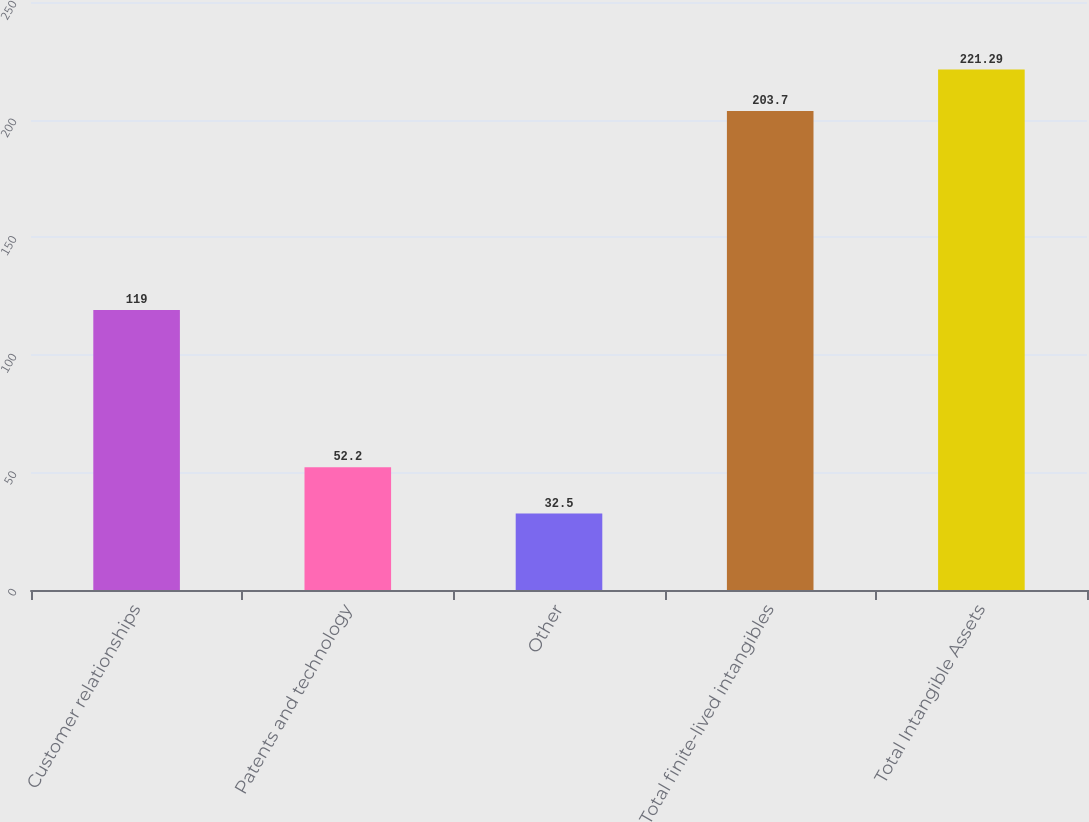Convert chart. <chart><loc_0><loc_0><loc_500><loc_500><bar_chart><fcel>Customer relationships<fcel>Patents and technology<fcel>Other<fcel>Total finite-lived intangibles<fcel>Total Intangible Assets<nl><fcel>119<fcel>52.2<fcel>32.5<fcel>203.7<fcel>221.29<nl></chart> 